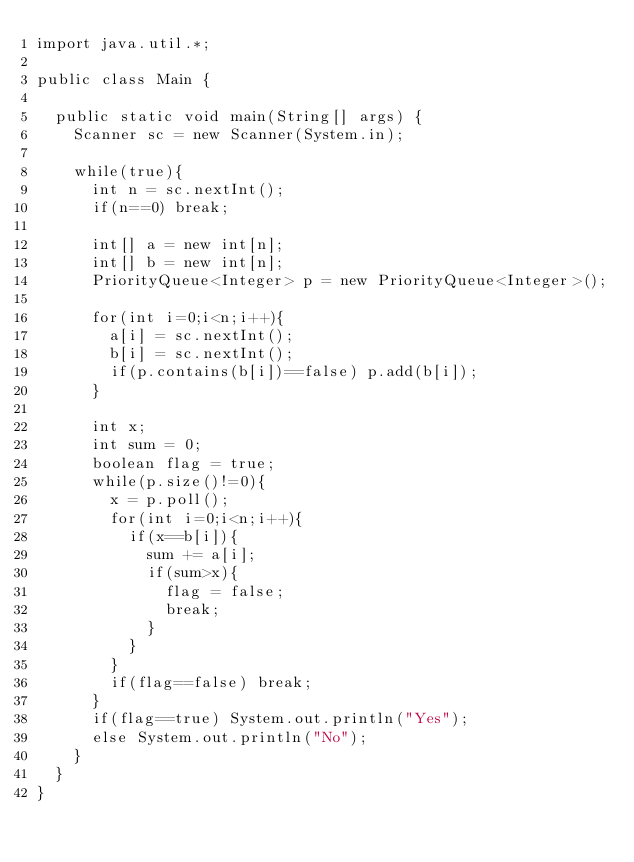<code> <loc_0><loc_0><loc_500><loc_500><_Java_>import java.util.*;

public class Main {
	
	public static void main(String[] args) {
		Scanner sc = new Scanner(System.in);
		
		while(true){
			int n = sc.nextInt();
			if(n==0) break;
			
			int[] a = new int[n];
			int[] b = new int[n];
			PriorityQueue<Integer> p = new PriorityQueue<Integer>();
			
			for(int i=0;i<n;i++){
				a[i] = sc.nextInt();
				b[i] = sc.nextInt();
				if(p.contains(b[i])==false) p.add(b[i]);
			}
			
			int x;
			int sum = 0;
			boolean flag = true;
			while(p.size()!=0){
				x = p.poll();
				for(int i=0;i<n;i++){
					if(x==b[i]){
						sum += a[i];
						if(sum>x){
							flag = false;
							break;
						}
					}
				}
				if(flag==false) break;
			}
			if(flag==true) System.out.println("Yes");
			else System.out.println("No");
		}	
	}	
}</code> 